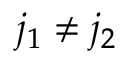<formula> <loc_0><loc_0><loc_500><loc_500>j _ { 1 } \ne j _ { 2 }</formula> 